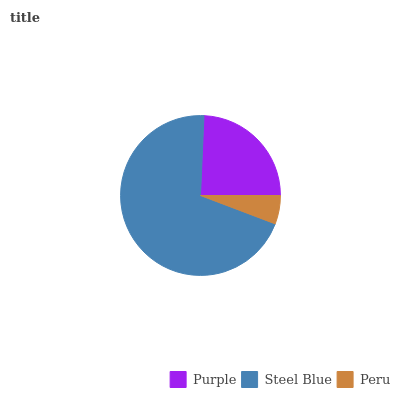Is Peru the minimum?
Answer yes or no. Yes. Is Steel Blue the maximum?
Answer yes or no. Yes. Is Steel Blue the minimum?
Answer yes or no. No. Is Peru the maximum?
Answer yes or no. No. Is Steel Blue greater than Peru?
Answer yes or no. Yes. Is Peru less than Steel Blue?
Answer yes or no. Yes. Is Peru greater than Steel Blue?
Answer yes or no. No. Is Steel Blue less than Peru?
Answer yes or no. No. Is Purple the high median?
Answer yes or no. Yes. Is Purple the low median?
Answer yes or no. Yes. Is Steel Blue the high median?
Answer yes or no. No. Is Peru the low median?
Answer yes or no. No. 